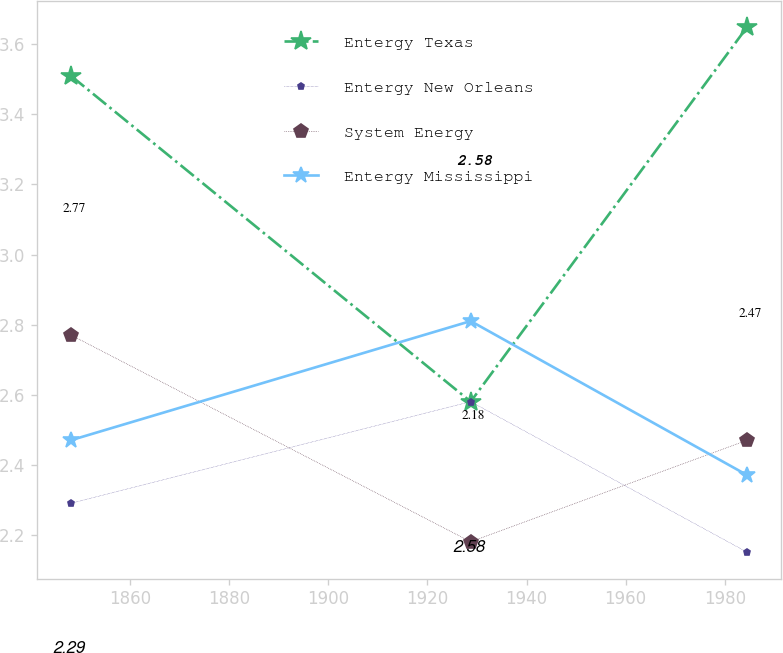Convert chart. <chart><loc_0><loc_0><loc_500><loc_500><line_chart><ecel><fcel>Entergy Texas<fcel>Entergy New Orleans<fcel>System Energy<fcel>Entergy Mississippi<nl><fcel>1848.06<fcel>3.51<fcel>2.29<fcel>2.77<fcel>2.47<nl><fcel>1928.72<fcel>2.58<fcel>2.58<fcel>2.18<fcel>2.81<nl><fcel>1984.54<fcel>3.65<fcel>2.15<fcel>2.47<fcel>2.37<nl></chart> 